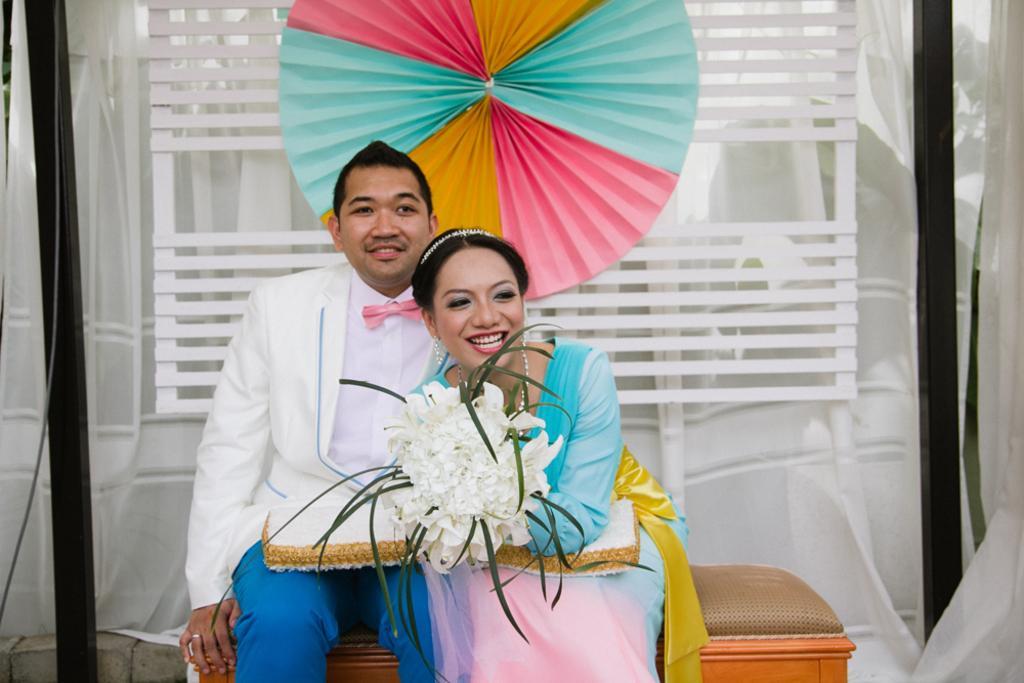Describe this image in one or two sentences. In this picture I can see a man and a woman smiling and sitting on the bench, woman holding a bouquet, and in the background there is a paper fan, there is a wooden object, there is cloth, these are looking like poles. 